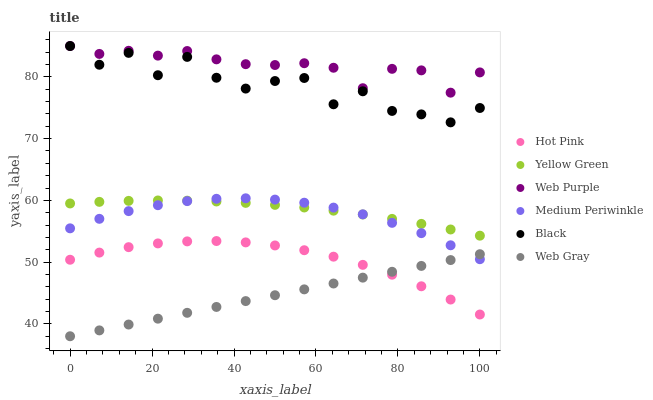Does Web Gray have the minimum area under the curve?
Answer yes or no. Yes. Does Web Purple have the maximum area under the curve?
Answer yes or no. Yes. Does Yellow Green have the minimum area under the curve?
Answer yes or no. No. Does Yellow Green have the maximum area under the curve?
Answer yes or no. No. Is Web Gray the smoothest?
Answer yes or no. Yes. Is Black the roughest?
Answer yes or no. Yes. Is Yellow Green the smoothest?
Answer yes or no. No. Is Yellow Green the roughest?
Answer yes or no. No. Does Web Gray have the lowest value?
Answer yes or no. Yes. Does Yellow Green have the lowest value?
Answer yes or no. No. Does Black have the highest value?
Answer yes or no. Yes. Does Yellow Green have the highest value?
Answer yes or no. No. Is Yellow Green less than Black?
Answer yes or no. Yes. Is Web Purple greater than Web Gray?
Answer yes or no. Yes. Does Medium Periwinkle intersect Yellow Green?
Answer yes or no. Yes. Is Medium Periwinkle less than Yellow Green?
Answer yes or no. No. Is Medium Periwinkle greater than Yellow Green?
Answer yes or no. No. Does Yellow Green intersect Black?
Answer yes or no. No. 